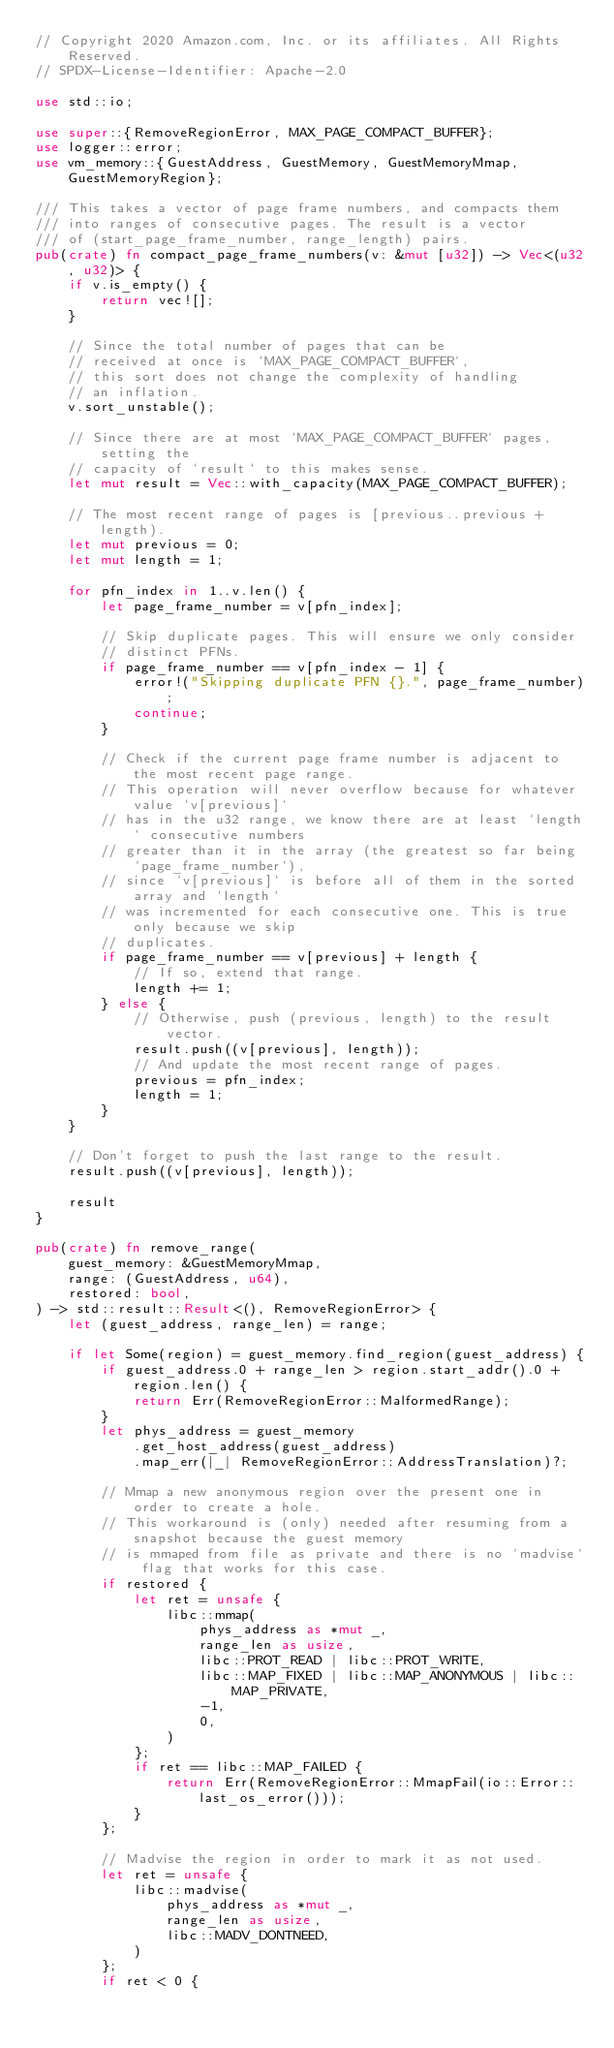Convert code to text. <code><loc_0><loc_0><loc_500><loc_500><_Rust_>// Copyright 2020 Amazon.com, Inc. or its affiliates. All Rights Reserved.
// SPDX-License-Identifier: Apache-2.0

use std::io;

use super::{RemoveRegionError, MAX_PAGE_COMPACT_BUFFER};
use logger::error;
use vm_memory::{GuestAddress, GuestMemory, GuestMemoryMmap, GuestMemoryRegion};

/// This takes a vector of page frame numbers, and compacts them
/// into ranges of consecutive pages. The result is a vector
/// of (start_page_frame_number, range_length) pairs.
pub(crate) fn compact_page_frame_numbers(v: &mut [u32]) -> Vec<(u32, u32)> {
    if v.is_empty() {
        return vec![];
    }

    // Since the total number of pages that can be
    // received at once is `MAX_PAGE_COMPACT_BUFFER`,
    // this sort does not change the complexity of handling
    // an inflation.
    v.sort_unstable();

    // Since there are at most `MAX_PAGE_COMPACT_BUFFER` pages, setting the
    // capacity of `result` to this makes sense.
    let mut result = Vec::with_capacity(MAX_PAGE_COMPACT_BUFFER);

    // The most recent range of pages is [previous..previous + length).
    let mut previous = 0;
    let mut length = 1;

    for pfn_index in 1..v.len() {
        let page_frame_number = v[pfn_index];

        // Skip duplicate pages. This will ensure we only consider
        // distinct PFNs.
        if page_frame_number == v[pfn_index - 1] {
            error!("Skipping duplicate PFN {}.", page_frame_number);
            continue;
        }

        // Check if the current page frame number is adjacent to the most recent page range.
        // This operation will never overflow because for whatever value `v[previous]`
        // has in the u32 range, we know there are at least `length` consecutive numbers
        // greater than it in the array (the greatest so far being `page_frame_number`),
        // since `v[previous]` is before all of them in the sorted array and `length`
        // was incremented for each consecutive one. This is true only because we skip
        // duplicates.
        if page_frame_number == v[previous] + length {
            // If so, extend that range.
            length += 1;
        } else {
            // Otherwise, push (previous, length) to the result vector.
            result.push((v[previous], length));
            // And update the most recent range of pages.
            previous = pfn_index;
            length = 1;
        }
    }

    // Don't forget to push the last range to the result.
    result.push((v[previous], length));

    result
}

pub(crate) fn remove_range(
    guest_memory: &GuestMemoryMmap,
    range: (GuestAddress, u64),
    restored: bool,
) -> std::result::Result<(), RemoveRegionError> {
    let (guest_address, range_len) = range;

    if let Some(region) = guest_memory.find_region(guest_address) {
        if guest_address.0 + range_len > region.start_addr().0 + region.len() {
            return Err(RemoveRegionError::MalformedRange);
        }
        let phys_address = guest_memory
            .get_host_address(guest_address)
            .map_err(|_| RemoveRegionError::AddressTranslation)?;

        // Mmap a new anonymous region over the present one in order to create a hole.
        // This workaround is (only) needed after resuming from a snapshot because the guest memory
        // is mmaped from file as private and there is no `madvise` flag that works for this case.
        if restored {
            let ret = unsafe {
                libc::mmap(
                    phys_address as *mut _,
                    range_len as usize,
                    libc::PROT_READ | libc::PROT_WRITE,
                    libc::MAP_FIXED | libc::MAP_ANONYMOUS | libc::MAP_PRIVATE,
                    -1,
                    0,
                )
            };
            if ret == libc::MAP_FAILED {
                return Err(RemoveRegionError::MmapFail(io::Error::last_os_error()));
            }
        };

        // Madvise the region in order to mark it as not used.
        let ret = unsafe {
            libc::madvise(
                phys_address as *mut _,
                range_len as usize,
                libc::MADV_DONTNEED,
            )
        };
        if ret < 0 {</code> 